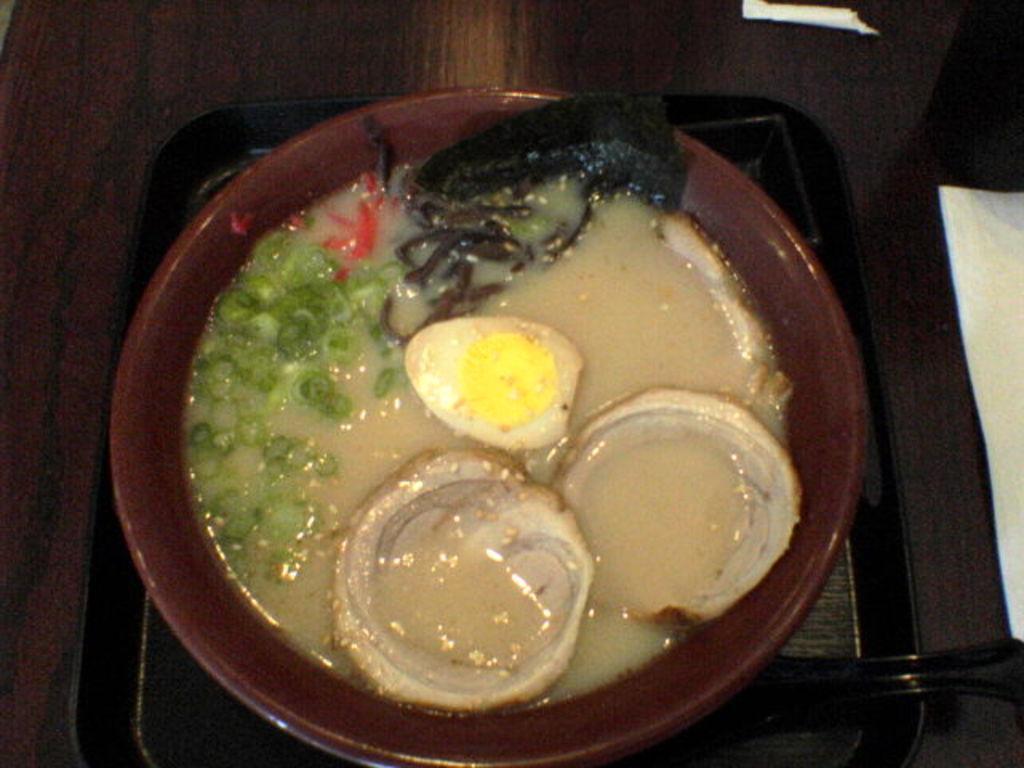How would you summarize this image in a sentence or two? In this picture we can see a table. On the table we can see the papers, tray. On the train we can see a bowl which contains food. 